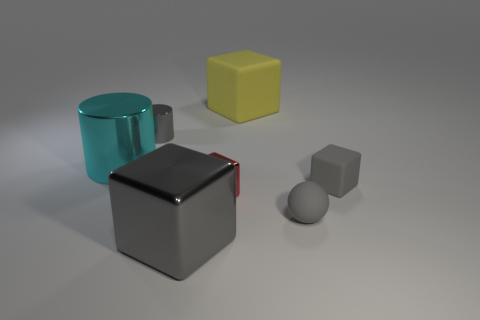What material is the block that is behind the matte block in front of the yellow cube behind the big cyan metallic cylinder made of?
Offer a very short reply. Rubber. There is a big block that is the same color as the tiny matte sphere; what is it made of?
Your response must be concise. Metal. Do the large cube that is behind the big gray object and the tiny cube that is left of the rubber sphere have the same color?
Your answer should be compact. No. What is the shape of the big object behind the metallic cylinder in front of the metal cylinder that is behind the big metallic cylinder?
Offer a terse response. Cube. There is a tiny thing that is both to the right of the gray shiny cube and to the left of the rubber sphere; what shape is it?
Give a very brief answer. Cube. There is a big metal object that is behind the gray block that is in front of the tiny red metallic object; how many yellow rubber blocks are in front of it?
Keep it short and to the point. 0. There is a red shiny object that is the same shape as the yellow matte thing; what size is it?
Your answer should be very brief. Small. Is there anything else that has the same size as the rubber sphere?
Keep it short and to the point. Yes. Does the object left of the gray metallic cylinder have the same material as the small cylinder?
Your answer should be very brief. Yes. There is another thing that is the same shape as the large cyan shiny thing; what is its color?
Offer a terse response. Gray. 